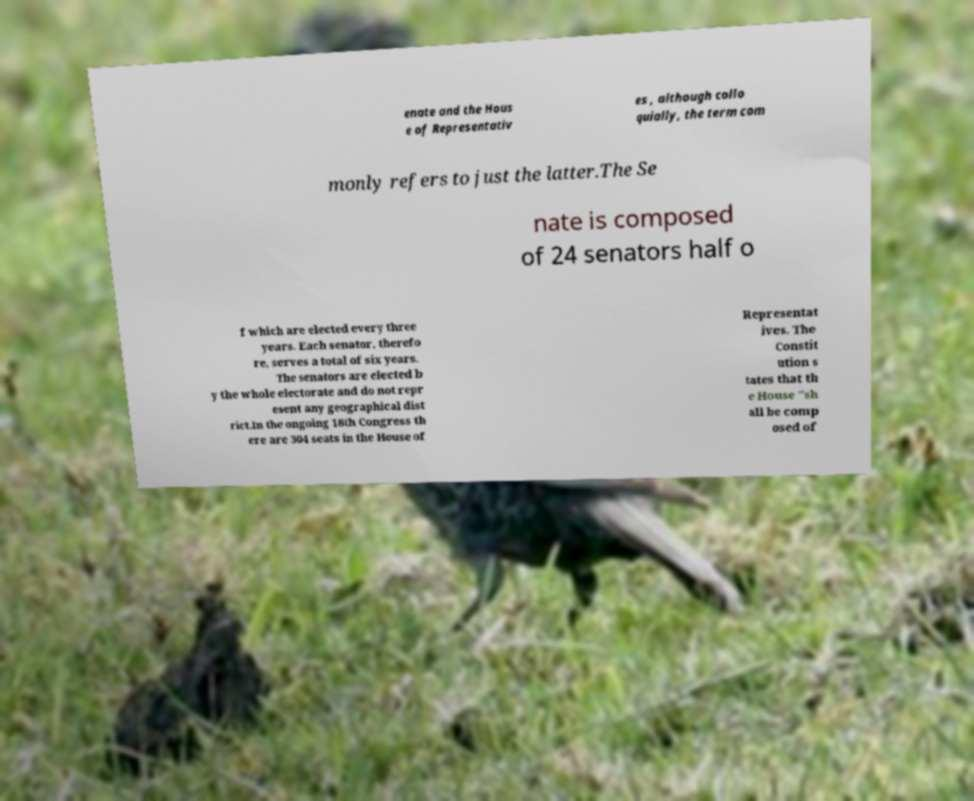Can you read and provide the text displayed in the image?This photo seems to have some interesting text. Can you extract and type it out for me? enate and the Hous e of Representativ es , although collo quially, the term com monly refers to just the latter.The Se nate is composed of 24 senators half o f which are elected every three years. Each senator, therefo re, serves a total of six years. The senators are elected b y the whole electorate and do not repr esent any geographical dist rict.In the ongoing 18th Congress th ere are 304 seats in the House of Representat ives. The Constit ution s tates that th e House "sh all be comp osed of 